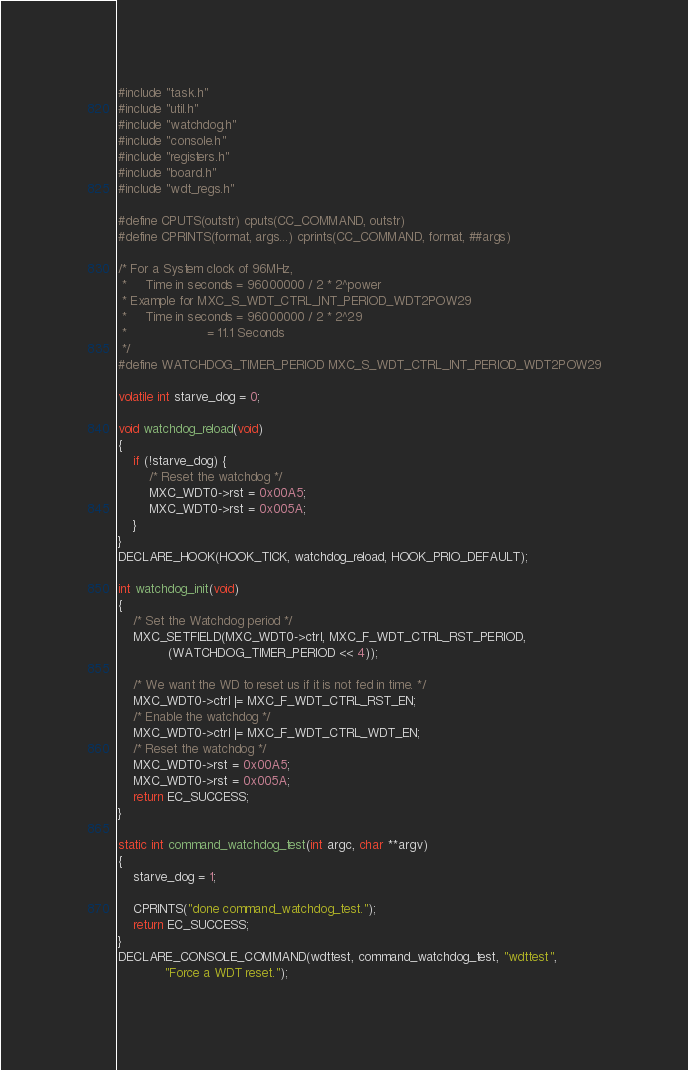Convert code to text. <code><loc_0><loc_0><loc_500><loc_500><_C_>#include "task.h"
#include "util.h"
#include "watchdog.h"
#include "console.h"
#include "registers.h"
#include "board.h"
#include "wdt_regs.h"

#define CPUTS(outstr) cputs(CC_COMMAND, outstr)
#define CPRINTS(format, args...) cprints(CC_COMMAND, format, ##args)

/* For a System clock of 96MHz, 
 *     Time in seconds = 96000000 / 2 * 2^power
 * Example for MXC_S_WDT_CTRL_INT_PERIOD_WDT2POW29
 *     Time in seconds = 96000000 / 2 * 2^29
 *                     = 11.1 Seconds
 */
#define WATCHDOG_TIMER_PERIOD MXC_S_WDT_CTRL_INT_PERIOD_WDT2POW29

volatile int starve_dog = 0;

void watchdog_reload(void)
{
	if (!starve_dog) {
		/* Reset the watchdog */
		MXC_WDT0->rst = 0x00A5;
		MXC_WDT0->rst = 0x005A;
	}
}
DECLARE_HOOK(HOOK_TICK, watchdog_reload, HOOK_PRIO_DEFAULT);

int watchdog_init(void)
{
	/* Set the Watchdog period */
	MXC_SETFIELD(MXC_WDT0->ctrl, MXC_F_WDT_CTRL_RST_PERIOD,
		     (WATCHDOG_TIMER_PERIOD << 4));

	/* We want the WD to reset us if it is not fed in time. */
	MXC_WDT0->ctrl |= MXC_F_WDT_CTRL_RST_EN;
	/* Enable the watchdog */
	MXC_WDT0->ctrl |= MXC_F_WDT_CTRL_WDT_EN;
	/* Reset the watchdog */
	MXC_WDT0->rst = 0x00A5;
	MXC_WDT0->rst = 0x005A;
	return EC_SUCCESS;
}

static int command_watchdog_test(int argc, char **argv)
{
	starve_dog = 1;

	CPRINTS("done command_watchdog_test.");
	return EC_SUCCESS;
}
DECLARE_CONSOLE_COMMAND(wdttest, command_watchdog_test, "wdttest",
			"Force a WDT reset.");
</code> 